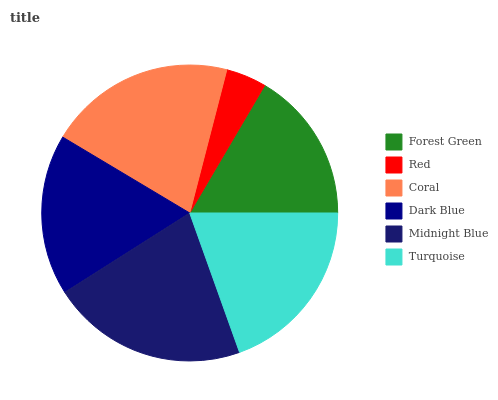Is Red the minimum?
Answer yes or no. Yes. Is Midnight Blue the maximum?
Answer yes or no. Yes. Is Coral the minimum?
Answer yes or no. No. Is Coral the maximum?
Answer yes or no. No. Is Coral greater than Red?
Answer yes or no. Yes. Is Red less than Coral?
Answer yes or no. Yes. Is Red greater than Coral?
Answer yes or no. No. Is Coral less than Red?
Answer yes or no. No. Is Turquoise the high median?
Answer yes or no. Yes. Is Dark Blue the low median?
Answer yes or no. Yes. Is Dark Blue the high median?
Answer yes or no. No. Is Turquoise the low median?
Answer yes or no. No. 